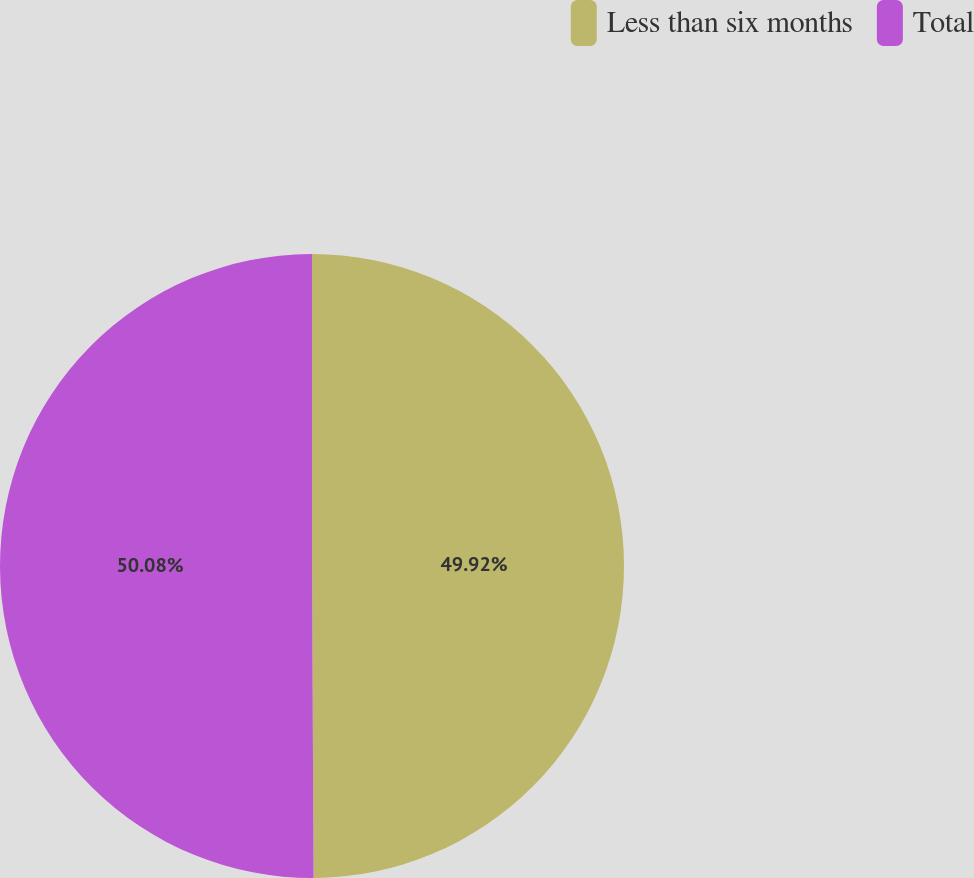Convert chart. <chart><loc_0><loc_0><loc_500><loc_500><pie_chart><fcel>Less than six months<fcel>Total<nl><fcel>49.92%<fcel>50.08%<nl></chart> 